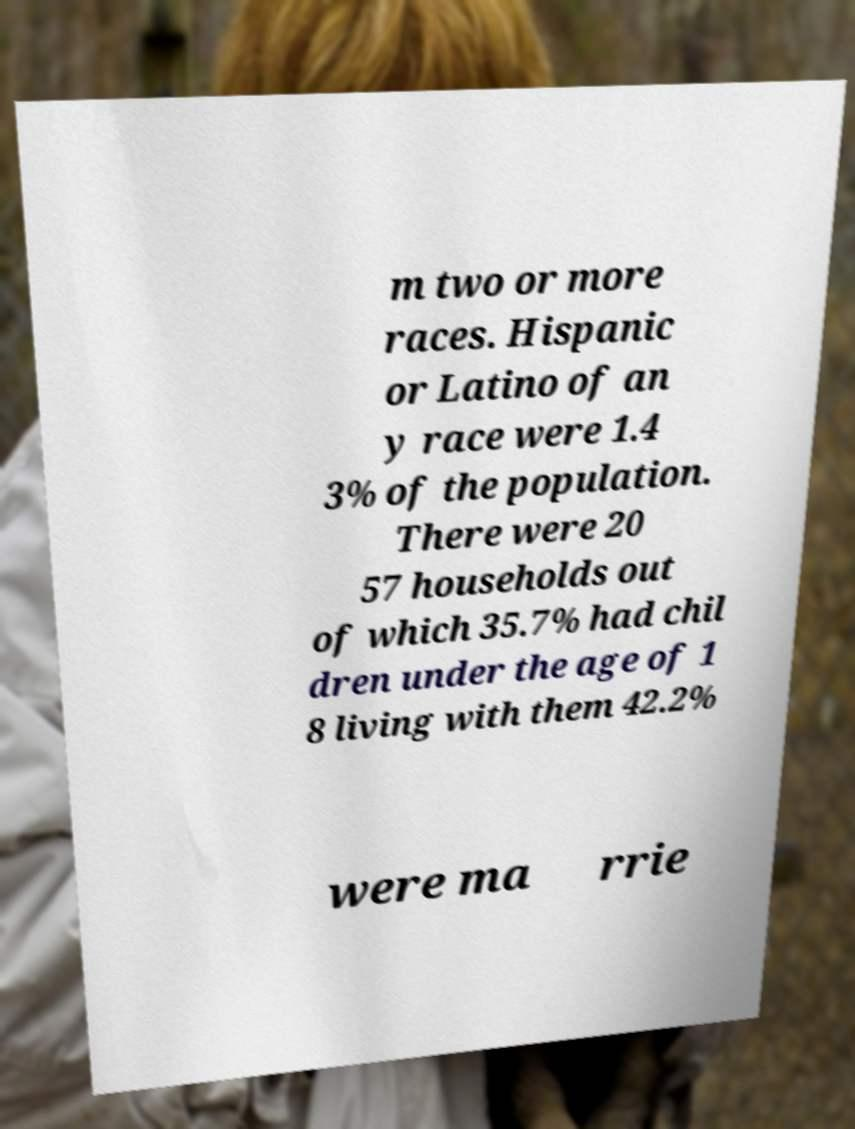Please identify and transcribe the text found in this image. m two or more races. Hispanic or Latino of an y race were 1.4 3% of the population. There were 20 57 households out of which 35.7% had chil dren under the age of 1 8 living with them 42.2% were ma rrie 